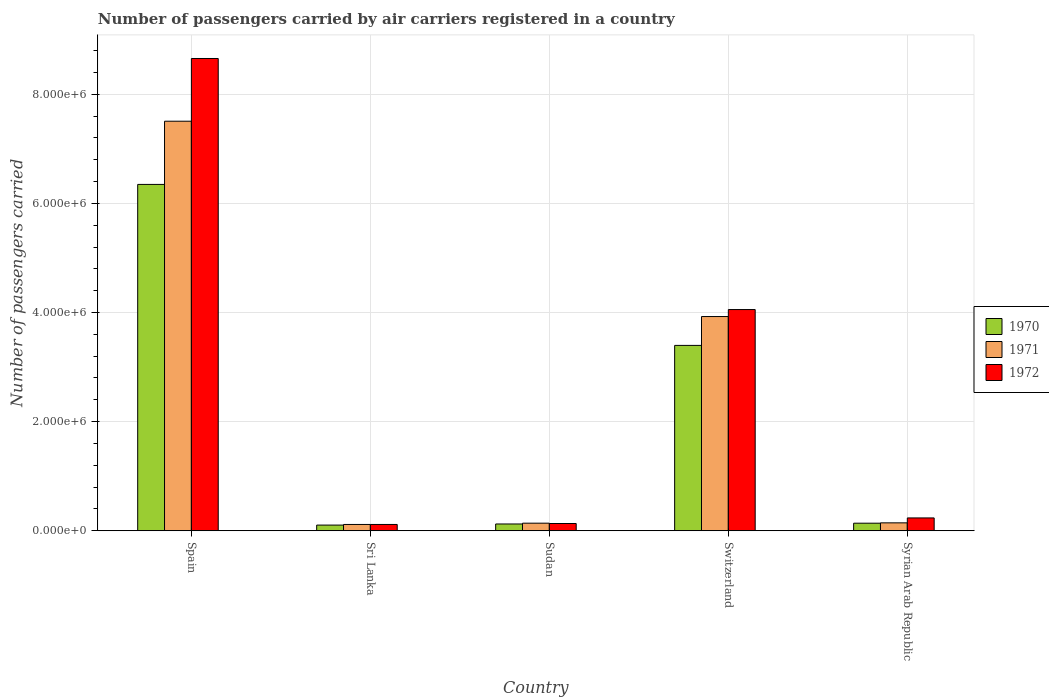How many different coloured bars are there?
Your response must be concise. 3. Are the number of bars per tick equal to the number of legend labels?
Your response must be concise. Yes. How many bars are there on the 5th tick from the right?
Your answer should be compact. 3. What is the label of the 4th group of bars from the left?
Provide a succinct answer. Switzerland. What is the number of passengers carried by air carriers in 1971 in Sudan?
Give a very brief answer. 1.40e+05. Across all countries, what is the maximum number of passengers carried by air carriers in 1971?
Make the answer very short. 7.51e+06. Across all countries, what is the minimum number of passengers carried by air carriers in 1972?
Make the answer very short. 1.16e+05. In which country was the number of passengers carried by air carriers in 1971 maximum?
Ensure brevity in your answer.  Spain. In which country was the number of passengers carried by air carriers in 1970 minimum?
Your answer should be very brief. Sri Lanka. What is the total number of passengers carried by air carriers in 1971 in the graph?
Give a very brief answer. 1.18e+07. What is the difference between the number of passengers carried by air carriers in 1971 in Switzerland and that in Syrian Arab Republic?
Your answer should be very brief. 3.78e+06. What is the difference between the number of passengers carried by air carriers in 1971 in Spain and the number of passengers carried by air carriers in 1972 in Sudan?
Keep it short and to the point. 7.37e+06. What is the average number of passengers carried by air carriers in 1972 per country?
Offer a very short reply. 2.64e+06. What is the difference between the number of passengers carried by air carriers of/in 1971 and number of passengers carried by air carriers of/in 1972 in Sri Lanka?
Provide a succinct answer. 0. In how many countries, is the number of passengers carried by air carriers in 1970 greater than 7200000?
Keep it short and to the point. 0. What is the ratio of the number of passengers carried by air carriers in 1972 in Sri Lanka to that in Syrian Arab Republic?
Your answer should be compact. 0.49. Is the number of passengers carried by air carriers in 1972 in Spain less than that in Sudan?
Keep it short and to the point. No. Is the difference between the number of passengers carried by air carriers in 1971 in Switzerland and Syrian Arab Republic greater than the difference between the number of passengers carried by air carriers in 1972 in Switzerland and Syrian Arab Republic?
Give a very brief answer. No. What is the difference between the highest and the second highest number of passengers carried by air carriers in 1972?
Provide a short and direct response. -8.42e+06. What is the difference between the highest and the lowest number of passengers carried by air carriers in 1972?
Your answer should be compact. 8.54e+06. Is the sum of the number of passengers carried by air carriers in 1971 in Sudan and Switzerland greater than the maximum number of passengers carried by air carriers in 1970 across all countries?
Your answer should be very brief. No. How many bars are there?
Keep it short and to the point. 15. Are all the bars in the graph horizontal?
Provide a short and direct response. No. Are the values on the major ticks of Y-axis written in scientific E-notation?
Your answer should be compact. Yes. Does the graph contain any zero values?
Offer a terse response. No. How many legend labels are there?
Your response must be concise. 3. How are the legend labels stacked?
Provide a succinct answer. Vertical. What is the title of the graph?
Your answer should be compact. Number of passengers carried by air carriers registered in a country. Does "1973" appear as one of the legend labels in the graph?
Your response must be concise. No. What is the label or title of the Y-axis?
Keep it short and to the point. Number of passengers carried. What is the Number of passengers carried of 1970 in Spain?
Your response must be concise. 6.35e+06. What is the Number of passengers carried in 1971 in Spain?
Give a very brief answer. 7.51e+06. What is the Number of passengers carried of 1972 in Spain?
Your answer should be very brief. 8.65e+06. What is the Number of passengers carried in 1970 in Sri Lanka?
Give a very brief answer. 1.05e+05. What is the Number of passengers carried of 1971 in Sri Lanka?
Your answer should be very brief. 1.16e+05. What is the Number of passengers carried in 1972 in Sri Lanka?
Offer a very short reply. 1.16e+05. What is the Number of passengers carried of 1970 in Sudan?
Offer a terse response. 1.25e+05. What is the Number of passengers carried of 1971 in Sudan?
Make the answer very short. 1.40e+05. What is the Number of passengers carried of 1972 in Sudan?
Offer a terse response. 1.33e+05. What is the Number of passengers carried in 1970 in Switzerland?
Offer a terse response. 3.40e+06. What is the Number of passengers carried of 1971 in Switzerland?
Give a very brief answer. 3.93e+06. What is the Number of passengers carried in 1972 in Switzerland?
Provide a short and direct response. 4.05e+06. What is the Number of passengers carried in 1970 in Syrian Arab Republic?
Ensure brevity in your answer.  1.39e+05. What is the Number of passengers carried in 1971 in Syrian Arab Republic?
Your answer should be compact. 1.45e+05. What is the Number of passengers carried in 1972 in Syrian Arab Republic?
Your answer should be compact. 2.36e+05. Across all countries, what is the maximum Number of passengers carried of 1970?
Offer a very short reply. 6.35e+06. Across all countries, what is the maximum Number of passengers carried in 1971?
Offer a very short reply. 7.51e+06. Across all countries, what is the maximum Number of passengers carried of 1972?
Your answer should be very brief. 8.65e+06. Across all countries, what is the minimum Number of passengers carried of 1970?
Your response must be concise. 1.05e+05. Across all countries, what is the minimum Number of passengers carried of 1971?
Offer a terse response. 1.16e+05. Across all countries, what is the minimum Number of passengers carried in 1972?
Provide a short and direct response. 1.16e+05. What is the total Number of passengers carried in 1970 in the graph?
Keep it short and to the point. 1.01e+07. What is the total Number of passengers carried of 1971 in the graph?
Give a very brief answer. 1.18e+07. What is the total Number of passengers carried of 1972 in the graph?
Give a very brief answer. 1.32e+07. What is the difference between the Number of passengers carried in 1970 in Spain and that in Sri Lanka?
Offer a very short reply. 6.24e+06. What is the difference between the Number of passengers carried of 1971 in Spain and that in Sri Lanka?
Provide a short and direct response. 7.39e+06. What is the difference between the Number of passengers carried of 1972 in Spain and that in Sri Lanka?
Make the answer very short. 8.54e+06. What is the difference between the Number of passengers carried in 1970 in Spain and that in Sudan?
Keep it short and to the point. 6.22e+06. What is the difference between the Number of passengers carried of 1971 in Spain and that in Sudan?
Provide a short and direct response. 7.37e+06. What is the difference between the Number of passengers carried of 1972 in Spain and that in Sudan?
Your answer should be very brief. 8.52e+06. What is the difference between the Number of passengers carried in 1970 in Spain and that in Switzerland?
Your answer should be very brief. 2.95e+06. What is the difference between the Number of passengers carried of 1971 in Spain and that in Switzerland?
Your answer should be very brief. 3.58e+06. What is the difference between the Number of passengers carried of 1972 in Spain and that in Switzerland?
Offer a terse response. 4.60e+06. What is the difference between the Number of passengers carried of 1970 in Spain and that in Syrian Arab Republic?
Give a very brief answer. 6.21e+06. What is the difference between the Number of passengers carried in 1971 in Spain and that in Syrian Arab Republic?
Provide a short and direct response. 7.36e+06. What is the difference between the Number of passengers carried of 1972 in Spain and that in Syrian Arab Republic?
Ensure brevity in your answer.  8.42e+06. What is the difference between the Number of passengers carried of 1970 in Sri Lanka and that in Sudan?
Offer a very short reply. -2.01e+04. What is the difference between the Number of passengers carried in 1971 in Sri Lanka and that in Sudan?
Ensure brevity in your answer.  -2.35e+04. What is the difference between the Number of passengers carried of 1972 in Sri Lanka and that in Sudan?
Give a very brief answer. -1.74e+04. What is the difference between the Number of passengers carried of 1970 in Sri Lanka and that in Switzerland?
Offer a very short reply. -3.29e+06. What is the difference between the Number of passengers carried in 1971 in Sri Lanka and that in Switzerland?
Give a very brief answer. -3.81e+06. What is the difference between the Number of passengers carried of 1972 in Sri Lanka and that in Switzerland?
Provide a succinct answer. -3.94e+06. What is the difference between the Number of passengers carried of 1970 in Sri Lanka and that in Syrian Arab Republic?
Provide a short and direct response. -3.44e+04. What is the difference between the Number of passengers carried of 1971 in Sri Lanka and that in Syrian Arab Republic?
Provide a succinct answer. -2.93e+04. What is the difference between the Number of passengers carried of 1972 in Sri Lanka and that in Syrian Arab Republic?
Provide a succinct answer. -1.20e+05. What is the difference between the Number of passengers carried in 1970 in Sudan and that in Switzerland?
Ensure brevity in your answer.  -3.27e+06. What is the difference between the Number of passengers carried in 1971 in Sudan and that in Switzerland?
Your response must be concise. -3.79e+06. What is the difference between the Number of passengers carried in 1972 in Sudan and that in Switzerland?
Your response must be concise. -3.92e+06. What is the difference between the Number of passengers carried in 1970 in Sudan and that in Syrian Arab Republic?
Your response must be concise. -1.43e+04. What is the difference between the Number of passengers carried of 1971 in Sudan and that in Syrian Arab Republic?
Your answer should be compact. -5800. What is the difference between the Number of passengers carried in 1972 in Sudan and that in Syrian Arab Republic?
Provide a succinct answer. -1.02e+05. What is the difference between the Number of passengers carried in 1970 in Switzerland and that in Syrian Arab Republic?
Offer a terse response. 3.26e+06. What is the difference between the Number of passengers carried of 1971 in Switzerland and that in Syrian Arab Republic?
Your answer should be very brief. 3.78e+06. What is the difference between the Number of passengers carried in 1972 in Switzerland and that in Syrian Arab Republic?
Keep it short and to the point. 3.82e+06. What is the difference between the Number of passengers carried of 1970 in Spain and the Number of passengers carried of 1971 in Sri Lanka?
Give a very brief answer. 6.23e+06. What is the difference between the Number of passengers carried of 1970 in Spain and the Number of passengers carried of 1972 in Sri Lanka?
Keep it short and to the point. 6.23e+06. What is the difference between the Number of passengers carried of 1971 in Spain and the Number of passengers carried of 1972 in Sri Lanka?
Your answer should be very brief. 7.39e+06. What is the difference between the Number of passengers carried of 1970 in Spain and the Number of passengers carried of 1971 in Sudan?
Your response must be concise. 6.21e+06. What is the difference between the Number of passengers carried of 1970 in Spain and the Number of passengers carried of 1972 in Sudan?
Your answer should be very brief. 6.21e+06. What is the difference between the Number of passengers carried in 1971 in Spain and the Number of passengers carried in 1972 in Sudan?
Provide a succinct answer. 7.37e+06. What is the difference between the Number of passengers carried of 1970 in Spain and the Number of passengers carried of 1971 in Switzerland?
Make the answer very short. 2.42e+06. What is the difference between the Number of passengers carried of 1970 in Spain and the Number of passengers carried of 1972 in Switzerland?
Your response must be concise. 2.29e+06. What is the difference between the Number of passengers carried of 1971 in Spain and the Number of passengers carried of 1972 in Switzerland?
Your response must be concise. 3.45e+06. What is the difference between the Number of passengers carried of 1970 in Spain and the Number of passengers carried of 1971 in Syrian Arab Republic?
Your response must be concise. 6.20e+06. What is the difference between the Number of passengers carried of 1970 in Spain and the Number of passengers carried of 1972 in Syrian Arab Republic?
Your answer should be very brief. 6.11e+06. What is the difference between the Number of passengers carried in 1971 in Spain and the Number of passengers carried in 1972 in Syrian Arab Republic?
Provide a succinct answer. 7.27e+06. What is the difference between the Number of passengers carried of 1970 in Sri Lanka and the Number of passengers carried of 1971 in Sudan?
Make the answer very short. -3.49e+04. What is the difference between the Number of passengers carried of 1970 in Sri Lanka and the Number of passengers carried of 1972 in Sudan?
Your response must be concise. -2.88e+04. What is the difference between the Number of passengers carried of 1971 in Sri Lanka and the Number of passengers carried of 1972 in Sudan?
Ensure brevity in your answer.  -1.74e+04. What is the difference between the Number of passengers carried in 1970 in Sri Lanka and the Number of passengers carried in 1971 in Switzerland?
Keep it short and to the point. -3.82e+06. What is the difference between the Number of passengers carried in 1970 in Sri Lanka and the Number of passengers carried in 1972 in Switzerland?
Your answer should be compact. -3.95e+06. What is the difference between the Number of passengers carried of 1971 in Sri Lanka and the Number of passengers carried of 1972 in Switzerland?
Your answer should be very brief. -3.94e+06. What is the difference between the Number of passengers carried of 1970 in Sri Lanka and the Number of passengers carried of 1971 in Syrian Arab Republic?
Provide a succinct answer. -4.07e+04. What is the difference between the Number of passengers carried in 1970 in Sri Lanka and the Number of passengers carried in 1972 in Syrian Arab Republic?
Offer a terse response. -1.31e+05. What is the difference between the Number of passengers carried in 1971 in Sri Lanka and the Number of passengers carried in 1972 in Syrian Arab Republic?
Keep it short and to the point. -1.20e+05. What is the difference between the Number of passengers carried of 1970 in Sudan and the Number of passengers carried of 1971 in Switzerland?
Your response must be concise. -3.80e+06. What is the difference between the Number of passengers carried of 1970 in Sudan and the Number of passengers carried of 1972 in Switzerland?
Your response must be concise. -3.93e+06. What is the difference between the Number of passengers carried in 1971 in Sudan and the Number of passengers carried in 1972 in Switzerland?
Offer a terse response. -3.91e+06. What is the difference between the Number of passengers carried of 1970 in Sudan and the Number of passengers carried of 1971 in Syrian Arab Republic?
Your answer should be very brief. -2.06e+04. What is the difference between the Number of passengers carried in 1970 in Sudan and the Number of passengers carried in 1972 in Syrian Arab Republic?
Your answer should be very brief. -1.11e+05. What is the difference between the Number of passengers carried of 1971 in Sudan and the Number of passengers carried of 1972 in Syrian Arab Republic?
Offer a terse response. -9.62e+04. What is the difference between the Number of passengers carried of 1970 in Switzerland and the Number of passengers carried of 1971 in Syrian Arab Republic?
Provide a succinct answer. 3.25e+06. What is the difference between the Number of passengers carried in 1970 in Switzerland and the Number of passengers carried in 1972 in Syrian Arab Republic?
Keep it short and to the point. 3.16e+06. What is the difference between the Number of passengers carried in 1971 in Switzerland and the Number of passengers carried in 1972 in Syrian Arab Republic?
Your answer should be very brief. 3.69e+06. What is the average Number of passengers carried of 1970 per country?
Keep it short and to the point. 2.02e+06. What is the average Number of passengers carried of 1971 per country?
Provide a short and direct response. 2.37e+06. What is the average Number of passengers carried of 1972 per country?
Give a very brief answer. 2.64e+06. What is the difference between the Number of passengers carried of 1970 and Number of passengers carried of 1971 in Spain?
Ensure brevity in your answer.  -1.16e+06. What is the difference between the Number of passengers carried in 1970 and Number of passengers carried in 1972 in Spain?
Your response must be concise. -2.31e+06. What is the difference between the Number of passengers carried of 1971 and Number of passengers carried of 1972 in Spain?
Your answer should be very brief. -1.15e+06. What is the difference between the Number of passengers carried in 1970 and Number of passengers carried in 1971 in Sri Lanka?
Your response must be concise. -1.14e+04. What is the difference between the Number of passengers carried of 1970 and Number of passengers carried of 1972 in Sri Lanka?
Your answer should be very brief. -1.14e+04. What is the difference between the Number of passengers carried of 1971 and Number of passengers carried of 1972 in Sri Lanka?
Offer a very short reply. 0. What is the difference between the Number of passengers carried of 1970 and Number of passengers carried of 1971 in Sudan?
Keep it short and to the point. -1.48e+04. What is the difference between the Number of passengers carried of 1970 and Number of passengers carried of 1972 in Sudan?
Make the answer very short. -8700. What is the difference between the Number of passengers carried in 1971 and Number of passengers carried in 1972 in Sudan?
Give a very brief answer. 6100. What is the difference between the Number of passengers carried of 1970 and Number of passengers carried of 1971 in Switzerland?
Make the answer very short. -5.29e+05. What is the difference between the Number of passengers carried in 1970 and Number of passengers carried in 1972 in Switzerland?
Provide a short and direct response. -6.57e+05. What is the difference between the Number of passengers carried of 1971 and Number of passengers carried of 1972 in Switzerland?
Provide a short and direct response. -1.28e+05. What is the difference between the Number of passengers carried of 1970 and Number of passengers carried of 1971 in Syrian Arab Republic?
Provide a short and direct response. -6300. What is the difference between the Number of passengers carried of 1970 and Number of passengers carried of 1972 in Syrian Arab Republic?
Provide a short and direct response. -9.67e+04. What is the difference between the Number of passengers carried in 1971 and Number of passengers carried in 1972 in Syrian Arab Republic?
Offer a terse response. -9.04e+04. What is the ratio of the Number of passengers carried in 1970 in Spain to that in Sri Lanka?
Offer a terse response. 60.68. What is the ratio of the Number of passengers carried of 1971 in Spain to that in Sri Lanka?
Offer a very short reply. 64.7. What is the ratio of the Number of passengers carried in 1972 in Spain to that in Sri Lanka?
Keep it short and to the point. 74.61. What is the ratio of the Number of passengers carried of 1970 in Spain to that in Sudan?
Your answer should be very brief. 50.9. What is the ratio of the Number of passengers carried of 1971 in Spain to that in Sudan?
Keep it short and to the point. 53.8. What is the ratio of the Number of passengers carried in 1972 in Spain to that in Sudan?
Keep it short and to the point. 64.88. What is the ratio of the Number of passengers carried in 1970 in Spain to that in Switzerland?
Ensure brevity in your answer.  1.87. What is the ratio of the Number of passengers carried of 1971 in Spain to that in Switzerland?
Offer a terse response. 1.91. What is the ratio of the Number of passengers carried of 1972 in Spain to that in Switzerland?
Provide a succinct answer. 2.13. What is the ratio of the Number of passengers carried in 1970 in Spain to that in Syrian Arab Republic?
Make the answer very short. 45.66. What is the ratio of the Number of passengers carried in 1971 in Spain to that in Syrian Arab Republic?
Keep it short and to the point. 51.65. What is the ratio of the Number of passengers carried of 1972 in Spain to that in Syrian Arab Republic?
Offer a terse response. 36.72. What is the ratio of the Number of passengers carried in 1970 in Sri Lanka to that in Sudan?
Offer a terse response. 0.84. What is the ratio of the Number of passengers carried of 1971 in Sri Lanka to that in Sudan?
Provide a succinct answer. 0.83. What is the ratio of the Number of passengers carried of 1972 in Sri Lanka to that in Sudan?
Provide a succinct answer. 0.87. What is the ratio of the Number of passengers carried in 1970 in Sri Lanka to that in Switzerland?
Offer a terse response. 0.03. What is the ratio of the Number of passengers carried in 1971 in Sri Lanka to that in Switzerland?
Ensure brevity in your answer.  0.03. What is the ratio of the Number of passengers carried of 1972 in Sri Lanka to that in Switzerland?
Your answer should be very brief. 0.03. What is the ratio of the Number of passengers carried in 1970 in Sri Lanka to that in Syrian Arab Republic?
Provide a short and direct response. 0.75. What is the ratio of the Number of passengers carried of 1971 in Sri Lanka to that in Syrian Arab Republic?
Your response must be concise. 0.8. What is the ratio of the Number of passengers carried of 1972 in Sri Lanka to that in Syrian Arab Republic?
Offer a very short reply. 0.49. What is the ratio of the Number of passengers carried in 1970 in Sudan to that in Switzerland?
Offer a very short reply. 0.04. What is the ratio of the Number of passengers carried in 1971 in Sudan to that in Switzerland?
Your response must be concise. 0.04. What is the ratio of the Number of passengers carried of 1972 in Sudan to that in Switzerland?
Your answer should be very brief. 0.03. What is the ratio of the Number of passengers carried in 1970 in Sudan to that in Syrian Arab Republic?
Provide a short and direct response. 0.9. What is the ratio of the Number of passengers carried of 1971 in Sudan to that in Syrian Arab Republic?
Provide a succinct answer. 0.96. What is the ratio of the Number of passengers carried of 1972 in Sudan to that in Syrian Arab Republic?
Ensure brevity in your answer.  0.57. What is the ratio of the Number of passengers carried of 1970 in Switzerland to that in Syrian Arab Republic?
Make the answer very short. 24.44. What is the ratio of the Number of passengers carried of 1971 in Switzerland to that in Syrian Arab Republic?
Provide a succinct answer. 27.02. What is the ratio of the Number of passengers carried in 1972 in Switzerland to that in Syrian Arab Republic?
Your response must be concise. 17.2. What is the difference between the highest and the second highest Number of passengers carried of 1970?
Offer a very short reply. 2.95e+06. What is the difference between the highest and the second highest Number of passengers carried of 1971?
Provide a succinct answer. 3.58e+06. What is the difference between the highest and the second highest Number of passengers carried of 1972?
Make the answer very short. 4.60e+06. What is the difference between the highest and the lowest Number of passengers carried in 1970?
Offer a terse response. 6.24e+06. What is the difference between the highest and the lowest Number of passengers carried of 1971?
Provide a succinct answer. 7.39e+06. What is the difference between the highest and the lowest Number of passengers carried of 1972?
Keep it short and to the point. 8.54e+06. 